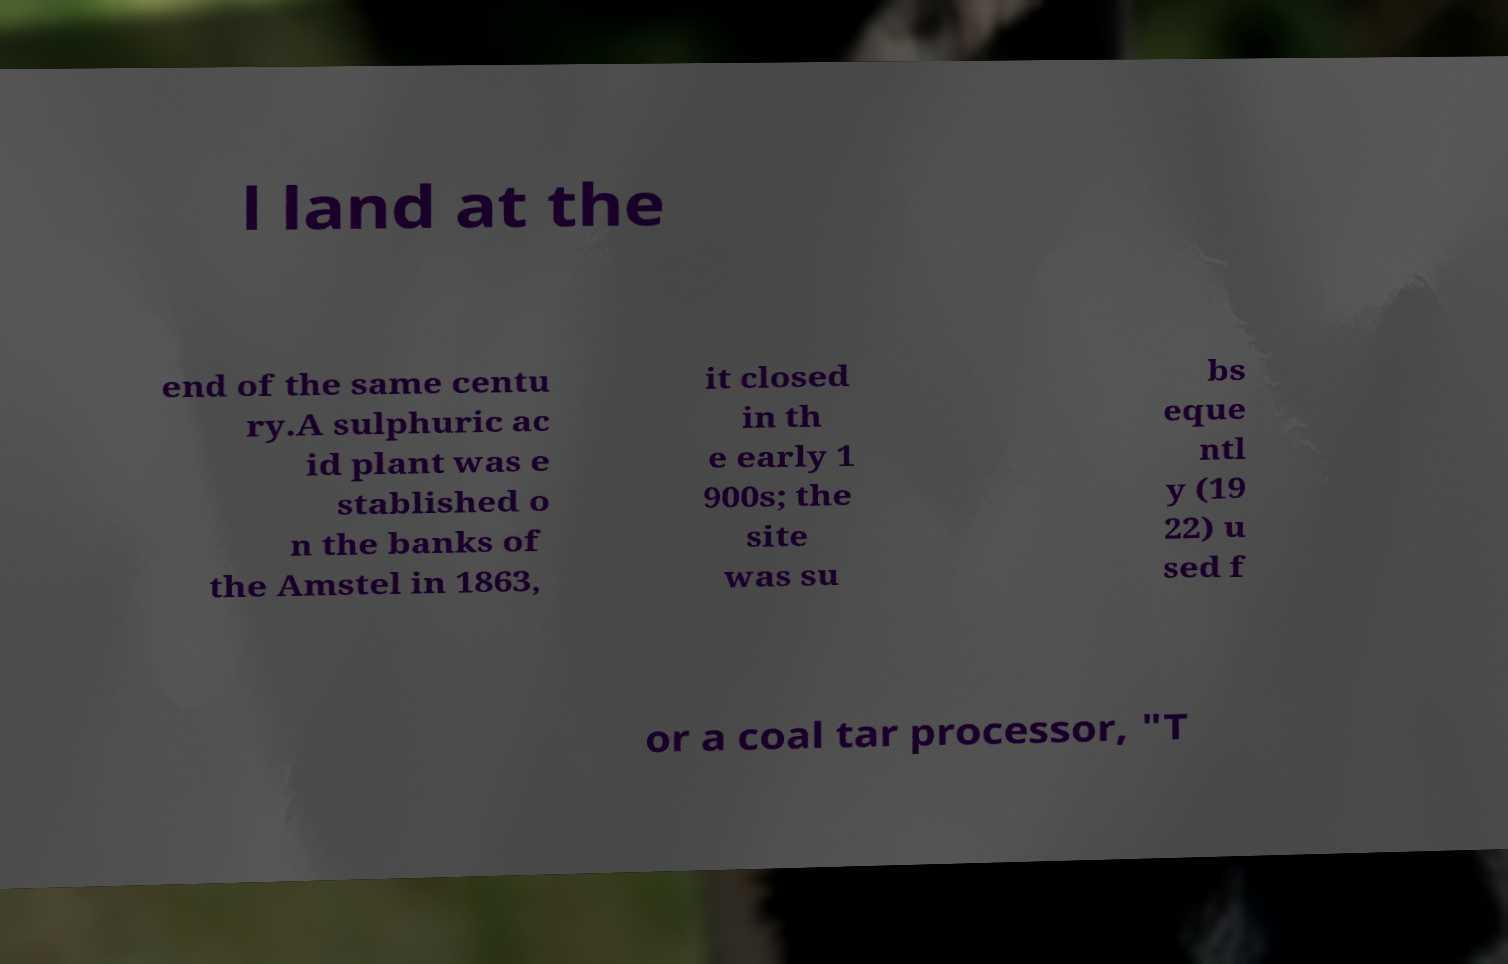Please read and relay the text visible in this image. What does it say? l land at the end of the same centu ry.A sulphuric ac id plant was e stablished o n the banks of the Amstel in 1863, it closed in th e early 1 900s; the site was su bs eque ntl y (19 22) u sed f or a coal tar processor, "T 